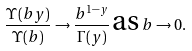<formula> <loc_0><loc_0><loc_500><loc_500>\frac { \Upsilon ( b y ) } { \Upsilon ( b ) } \rightarrow \frac { b ^ { 1 - y } } { \Gamma ( y ) } \, \text {as} \, b \rightarrow 0 .</formula> 